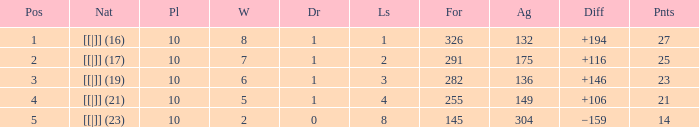 How many games had a deficit of 175?  1.0. 